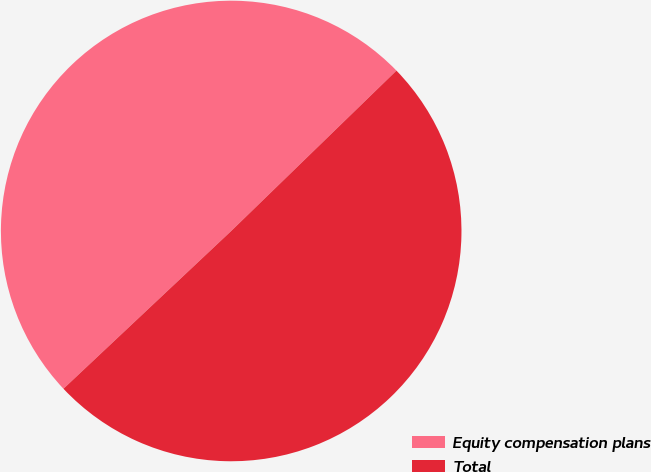Convert chart. <chart><loc_0><loc_0><loc_500><loc_500><pie_chart><fcel>Equity compensation plans<fcel>Total<nl><fcel>49.75%<fcel>50.25%<nl></chart> 